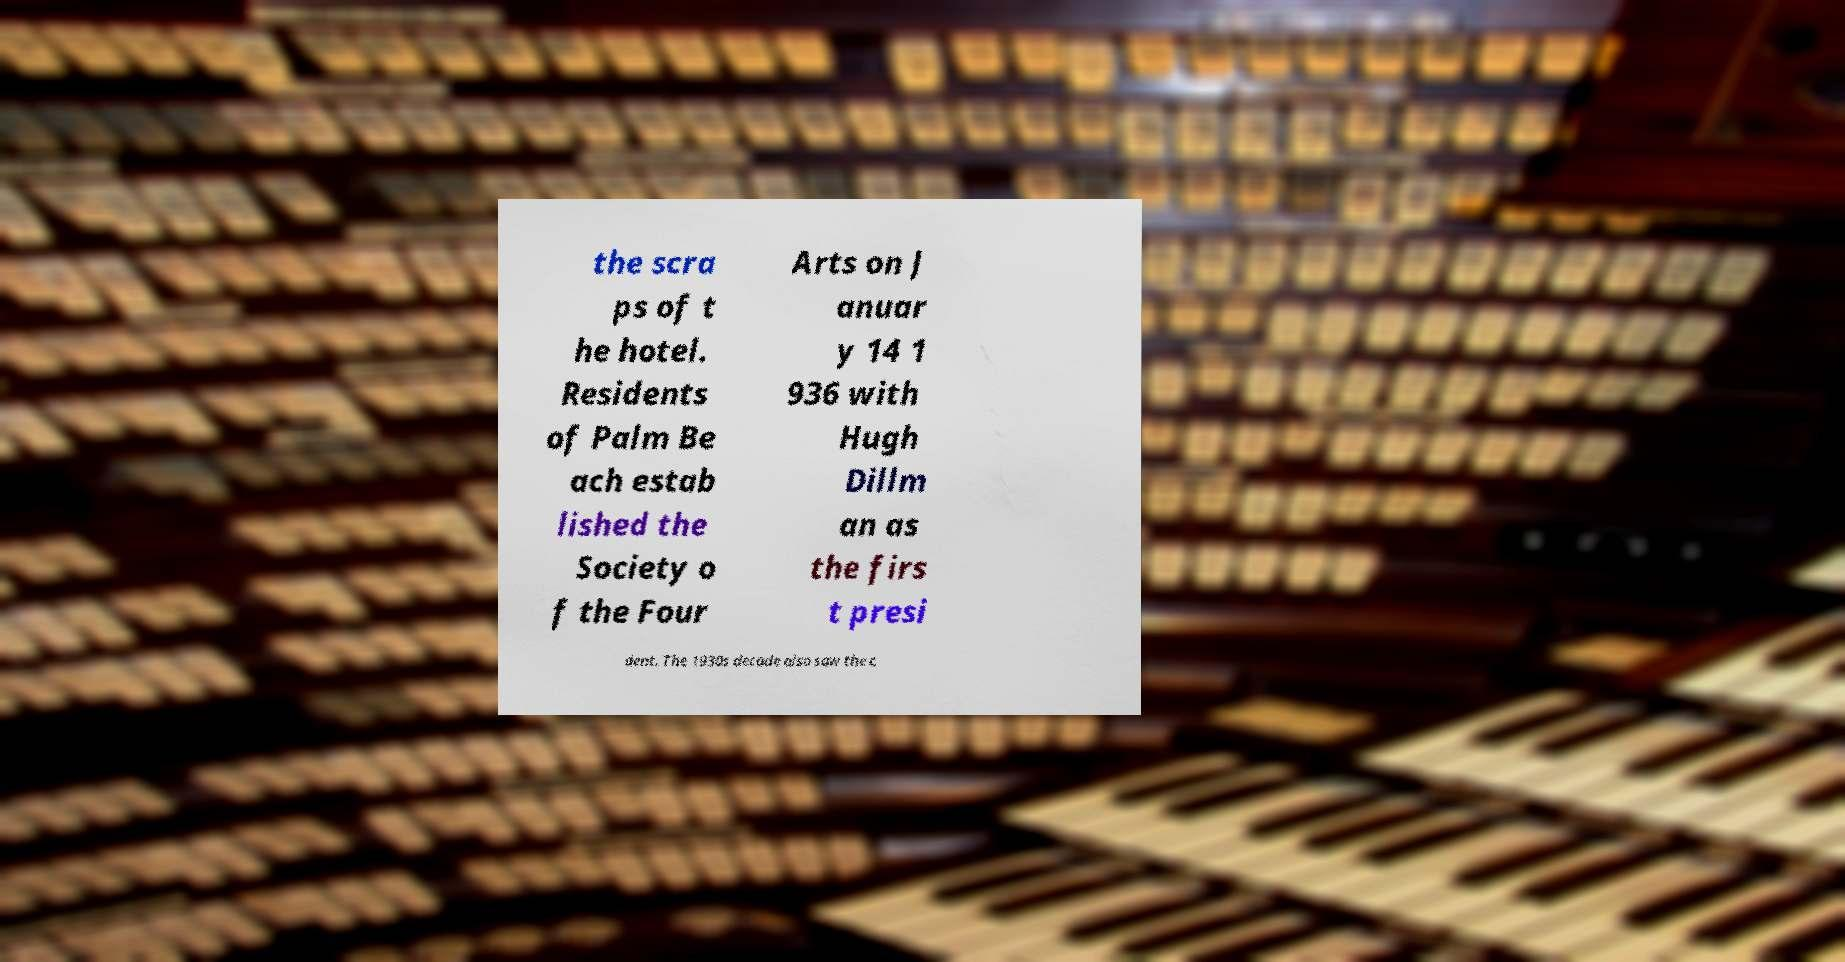I need the written content from this picture converted into text. Can you do that? the scra ps of t he hotel. Residents of Palm Be ach estab lished the Society o f the Four Arts on J anuar y 14 1 936 with Hugh Dillm an as the firs t presi dent. The 1930s decade also saw the c 